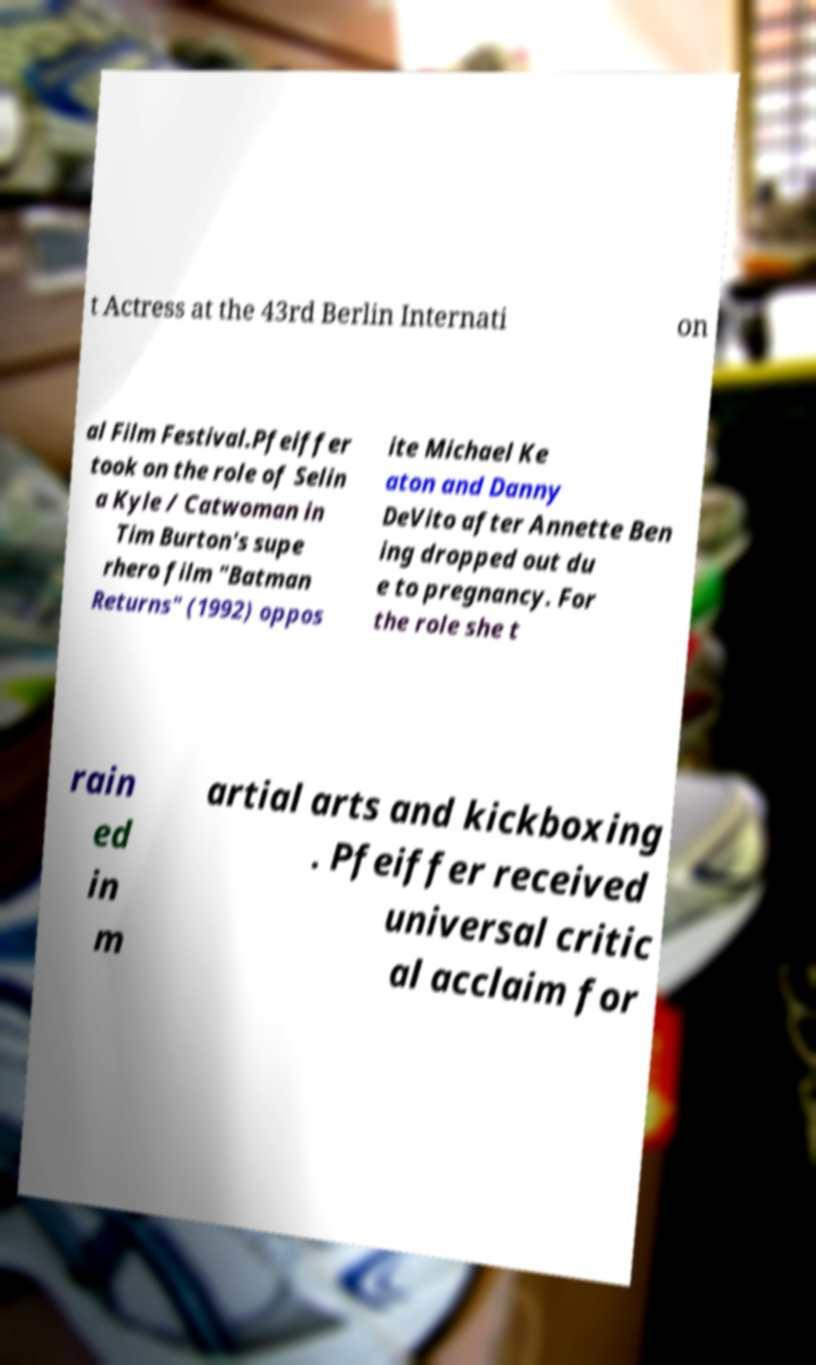Can you read and provide the text displayed in the image?This photo seems to have some interesting text. Can you extract and type it out for me? t Actress at the 43rd Berlin Internati on al Film Festival.Pfeiffer took on the role of Selin a Kyle / Catwoman in Tim Burton's supe rhero film "Batman Returns" (1992) oppos ite Michael Ke aton and Danny DeVito after Annette Ben ing dropped out du e to pregnancy. For the role she t rain ed in m artial arts and kickboxing . Pfeiffer received universal critic al acclaim for 